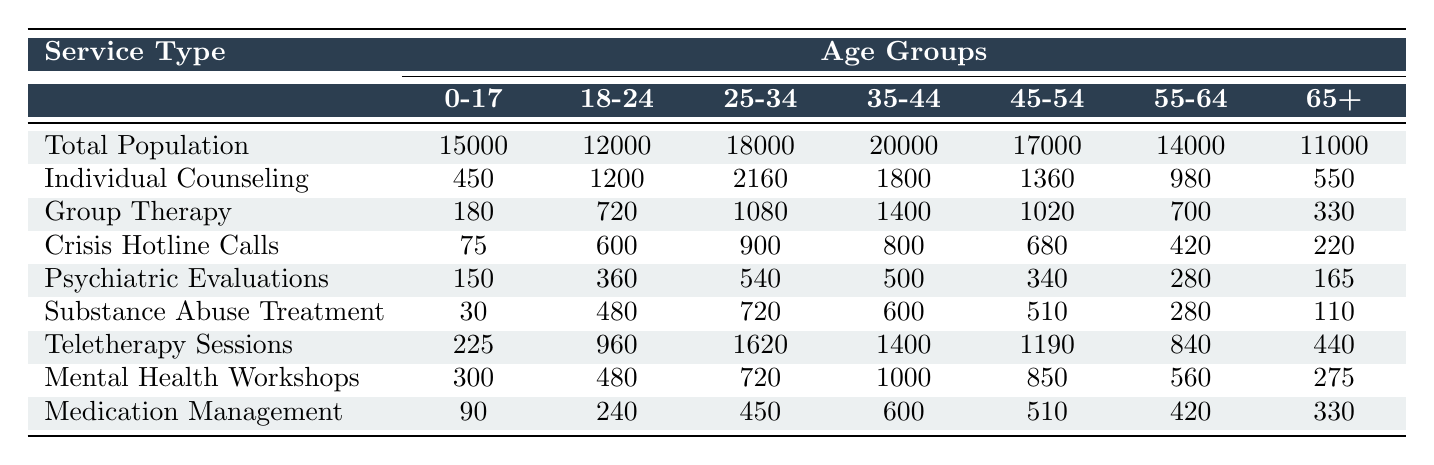What is the total population of the 35-44 age group? The total population for each age group is listed in the table, and the value for the 35-44 age group is 20,000.
Answer: 20,000 How many individual counseling sessions were held for the 25-34 age group? The number of individual counseling sessions for the 25-34 age group is found directly in the table, which shows 2,160 sessions.
Answer: 2,160 Which age group had the highest attendance in mental health workshops? By comparing the values for mental health workshops attendance across all age groups, the 35-44 age group shows the highest attendance at 1,000.
Answer: 35-44 What is the total number of crisis hotline calls made across all age groups? To find the total, we add the values of crisis hotline calls for all age groups: 75 + 600 + 900 + 800 + 680 + 420 + 220 = 3,695.
Answer: 3,695 Which age group has the lowest number of substance abuse treatment sessions? Looking at the substance abuse treatment data, the age group 0-17 has the lowest number at 30 sessions.
Answer: 0-17 On average, how many teletherapy sessions were conducted per age group? To find the average, we add the teletherapy sessions: 225 + 960 + 1620 + 1400 + 1190 + 840 + 440 = 5,675. Then divide by the number of age groups (7): 5,675 / 7 ≈ 810.71.
Answer: 810.71 Is the number of group therapy attendees higher in the 55-64 age group than in the 45-54 age group? Comparing the values in the table, the 55-64 age group has 700 attendees, and the 45-54 age group has 1,020 attendees, meaning the 55-64 age group has fewer attendees.
Answer: No What is the difference between the number of psychiatric evaluations in the 18-24 and 65+ age groups? The number of psychiatric evaluations for the 18-24 age group is 360, and for the 65+ age group, it is 165. The difference is 360 - 165 = 195.
Answer: 195 Which age group utilizes teletherapy the least? The table indicates that the 65+ age group uses teletherapy the least, with 440 sessions.
Answer: 65+ How many more individual counseling sessions does the 25-34 age group have compared to the 55-64 age group? The 25-34 age group has 2,160 individual counseling sessions, while the 55-64 age group has 980 sessions. The difference is 2,160 - 980 = 1,180.
Answer: 1,180 